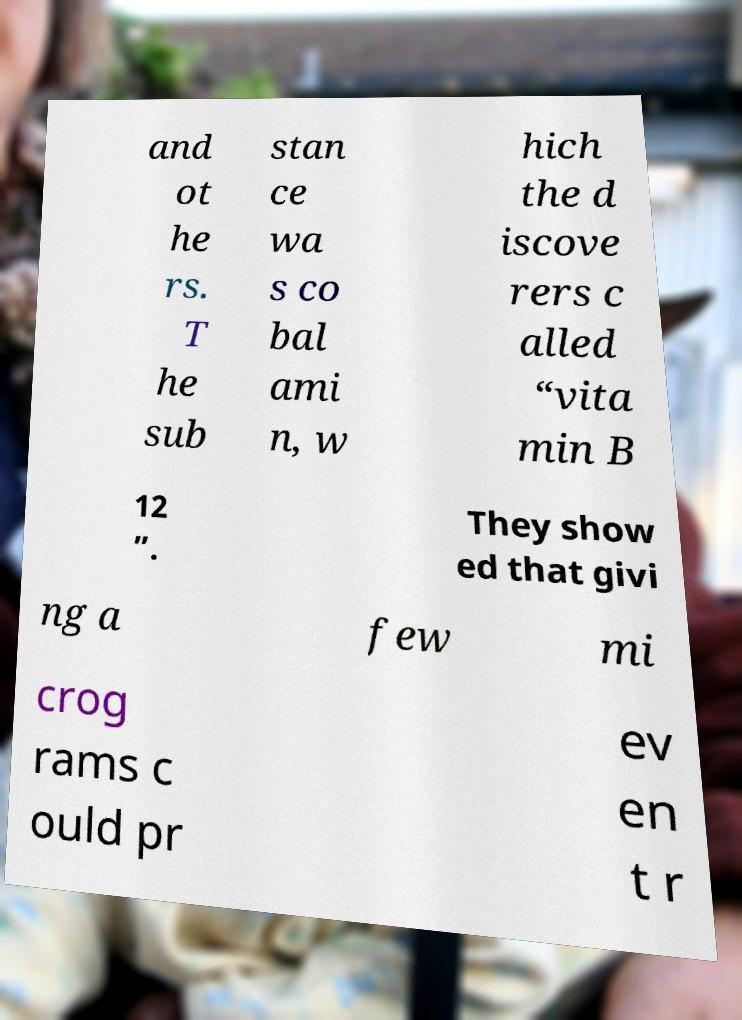Can you accurately transcribe the text from the provided image for me? and ot he rs. T he sub stan ce wa s co bal ami n, w hich the d iscove rers c alled “vita min B 12 ”. They show ed that givi ng a few mi crog rams c ould pr ev en t r 